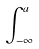Convert formula to latex. <formula><loc_0><loc_0><loc_500><loc_500>\int _ { - \infty } ^ { a }</formula> 